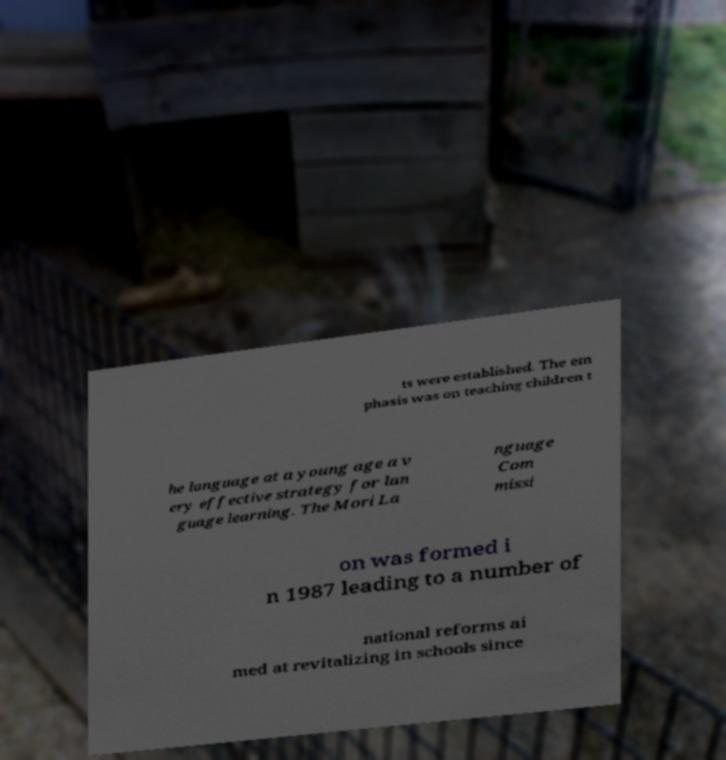Please identify and transcribe the text found in this image. ts were established. The em phasis was on teaching children t he language at a young age a v ery effective strategy for lan guage learning. The Mori La nguage Com missi on was formed i n 1987 leading to a number of national reforms ai med at revitalizing in schools since 